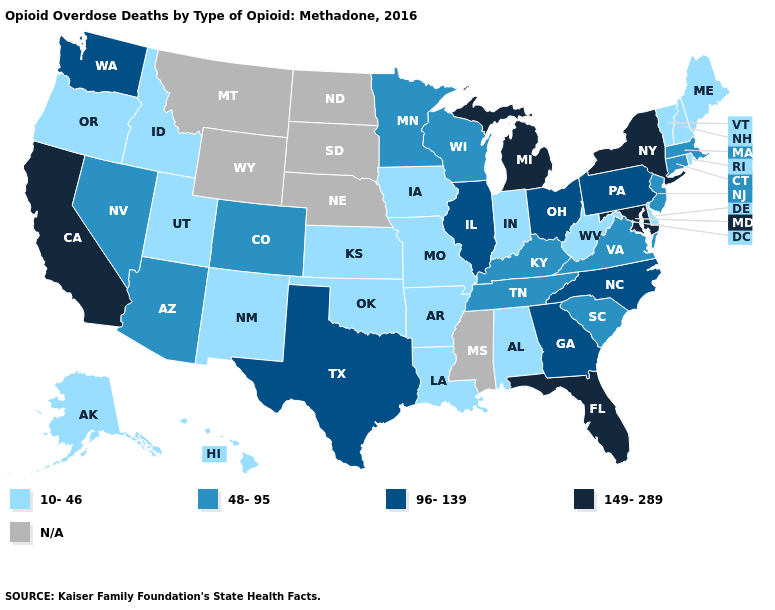Is the legend a continuous bar?
Keep it brief. No. What is the value of Georgia?
Concise answer only. 96-139. Name the states that have a value in the range 48-95?
Quick response, please. Arizona, Colorado, Connecticut, Kentucky, Massachusetts, Minnesota, Nevada, New Jersey, South Carolina, Tennessee, Virginia, Wisconsin. What is the lowest value in states that border New Jersey?
Short answer required. 10-46. Does Alabama have the lowest value in the USA?
Give a very brief answer. Yes. Name the states that have a value in the range N/A?
Keep it brief. Mississippi, Montana, Nebraska, North Dakota, South Dakota, Wyoming. Does New York have the highest value in the Northeast?
Give a very brief answer. Yes. What is the highest value in the USA?
Keep it brief. 149-289. Name the states that have a value in the range N/A?
Be succinct. Mississippi, Montana, Nebraska, North Dakota, South Dakota, Wyoming. Name the states that have a value in the range 149-289?
Keep it brief. California, Florida, Maryland, Michigan, New York. Name the states that have a value in the range 10-46?
Be succinct. Alabama, Alaska, Arkansas, Delaware, Hawaii, Idaho, Indiana, Iowa, Kansas, Louisiana, Maine, Missouri, New Hampshire, New Mexico, Oklahoma, Oregon, Rhode Island, Utah, Vermont, West Virginia. Name the states that have a value in the range 96-139?
Concise answer only. Georgia, Illinois, North Carolina, Ohio, Pennsylvania, Texas, Washington. What is the highest value in states that border Ohio?
Short answer required. 149-289. Among the states that border Missouri , which have the highest value?
Quick response, please. Illinois. 